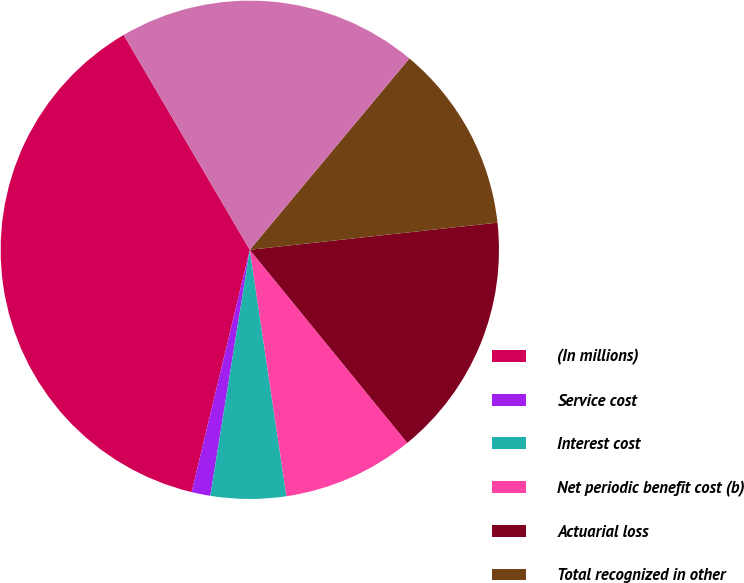Convert chart to OTSL. <chart><loc_0><loc_0><loc_500><loc_500><pie_chart><fcel>(In millions)<fcel>Service cost<fcel>Interest cost<fcel>Net periodic benefit cost (b)<fcel>Actuarial loss<fcel>Total recognized in other<fcel>Total recognized in net<nl><fcel>37.8%<fcel>1.22%<fcel>4.88%<fcel>8.54%<fcel>15.85%<fcel>12.2%<fcel>19.51%<nl></chart> 